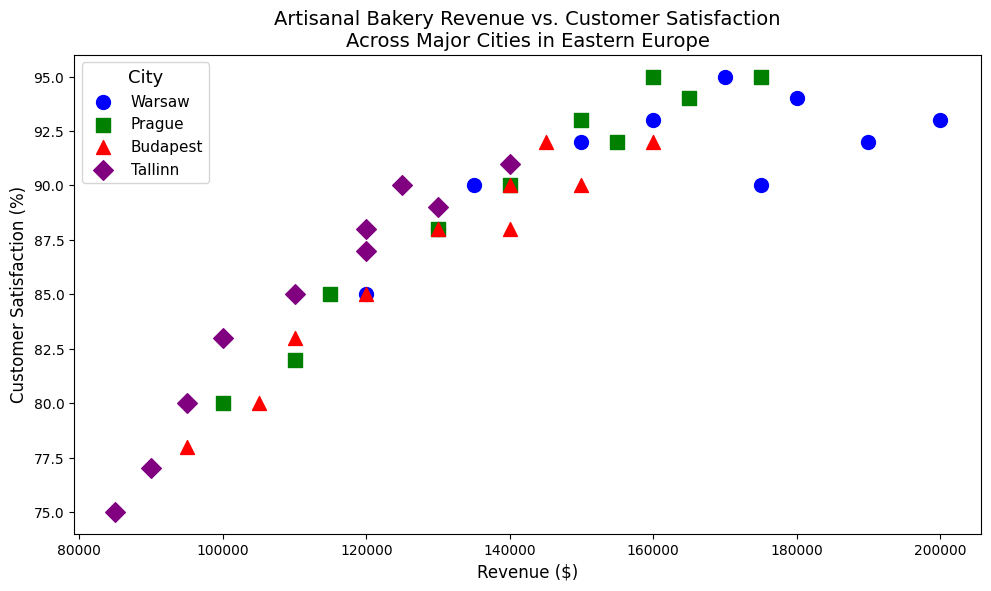Which city had the highest revenue in 2022? To answer this, look for the highest revenue point on the scatter plot for 2022. Check the color and marker shape associated with this point to identify the city.
Answer: Warsaw Which city experienced the highest customer satisfaction in 2019? Locate the data points for 2019 across different cities, and find the point with the highest customer satisfaction percentage. Identify the city by checking the color and marker shape.
Answer: Prague Compare the revenue of Budapest and Tallinn in 2016. Which city had higher revenue? Locate the 2016 data points for both Budapest and Tallinn. Compare the revenue values of these two points directly.
Answer: Budapest By how much did customer satisfaction in Prague increase from 2013 to 2022? Check the customer satisfaction value for Prague in both 2013 and 2022. Subtract the 2013 value from the 2022 value to find the increase. Calculation: 95 (2022) - 80 (2013).
Answer: 15% Which city showed the most consistent increase in revenue from 2013 to 2022? Review the trend of revenue across the years for each city. The city with the most consistent upward trend without significant dips would be the answer.
Answer: Warsaw Is there a general positive correlation between revenue and customer satisfaction across the cities? Observe the overall pattern of the scatter plot. If the points generally trend from lower left (low revenue, low satisfaction) to upper right (high revenue, high satisfaction), it indicates a positive correlation.
Answer: Yes In which year did Warsaw see the most significant drop in customer satisfaction, comparing to the previous year? Examine Warsaw's customer satisfaction values year by year, noting the differences. The year with the largest negative difference indicates the most significant drop. Calculation: 2020 (90) - 2019 (94) = -4.
Answer: 2020 Which city had the lowest revenue in 2013 and what was the customer satisfaction percentage at that revenue? Identify the lowest revenue data point for 2013 and refer to the respective city and its customer satisfaction percentage.
Answer: Tallinn, 75% How did the revenue trend in Budapest between 2019 and 2020 compare to other cities? Compare the change in revenue between 2019 and 2020 across all cities. Determine if Budapest's trend matches or diverges from the general pattern of other cities.
Answer: Budapest's revenue decreased, unlike other cities which generally saw an increase What's the average customer satisfaction for Tallinn over the decade? Sum up the customer satisfaction values for Tallinn from 2013 to 2022 and divide by the number of years (10). Calculation: (75 + 77 + 80 + 83 + 85 + 88 + 90 + 87 + 89 + 91)/10 = 84.5.
Answer: 84.5% 